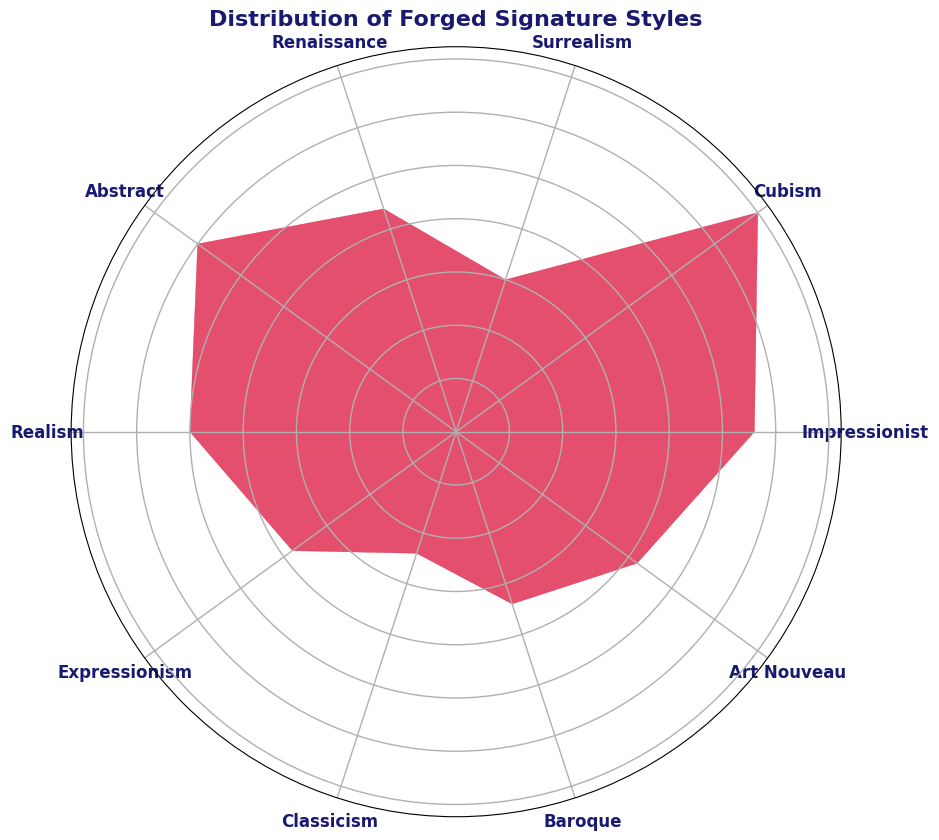What is the most common forged signature style? The most common forged signature style is identified by looking for the segment with the largest angle (or the highest point on a radius in the rose chart). The segment labeled "Cubism" has the highest frequency of 35, making it the most common.
Answer: Cubism Which forged signature style has the least frequency? To find the least common signature style, identify the smallest segment in the rose chart. The style labeled "Classicism" has the smallest frequency of 12.
Answer: Classicism How many signature styles have a frequency greater than 20? To determine how many styles have frequencies greater than 20, count the segments that have points exceeding the 20 frequency mark. The styles that meet this criteria are "Cubism" (35), "Impressionist" (28), "Abstract" (30), "Realism" (25), and "Renaissance" (22). This makes a total of 5 styles.
Answer: 5 What is the total frequency of the styles "Surrealism" and "Baroque"? To find the combined frequency of "Surrealism" and "Baroque", add their frequencies: 15 (Surrealism) + 17 (Baroque) = 32.
Answer: 32 Compare the frequency of "Impressionist" and "Art Nouveau." Which one is more common? Compare the heights of the segments labeled "Impressionist" and "Art Nouveau". "Impressionist" has a frequency of 28, whereas "Art Nouveau" has 21. Therefore, "Impressionist" is more common.
Answer: Impressionist Which signature styles have a frequency within the range of 15 to 25? Identify the segments whose frequencies fall between 15 and 25. The styles are "Surrealism" (15), "Realism" (25), "Expressionism" (19), "Classicism" (12) - not included as it is not within the range. So, the ones within the range are "Surrealism," "Realism," "Expressionism," "Baroque" (17) and "Art Nouveau" (21).
Answer: Surrealism, Realism, Expressionism, Baroque, Art Nouveau What is the average frequency of the signature styles? To calculate the average frequency, sum up all the frequencies and divide by the number of styles: (28+35+15+22+30+25+19+12+17+21) = 224. Divide 224 by 10 (number of styles) to obtain the average 224/10 = 22.4.
Answer: 22.4 How does the frequency of "Renaissance" compare to "Expressionism"? Compare the heights of the segments labeled "Renaissance" and "Expressionism." "Renaissance" has a frequency of 22, and "Expressionism" has 19. Therefore, "Renaissance" is more common than "Expressionism."
Answer: Renaissance 